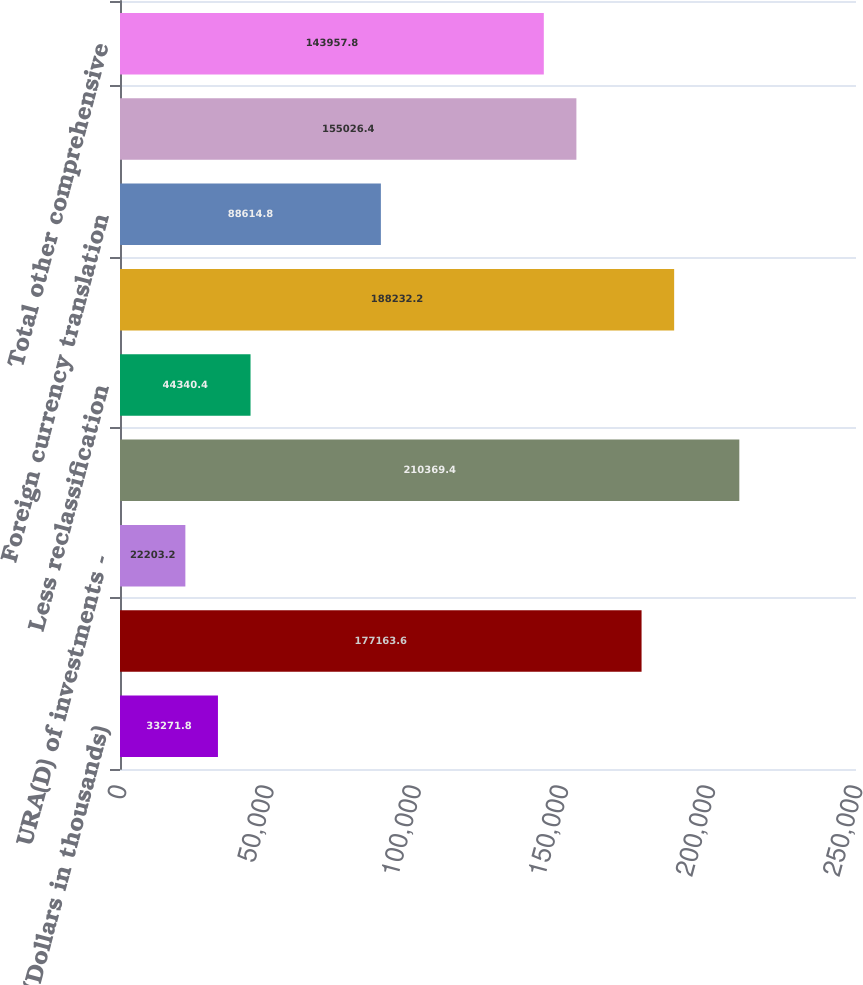Convert chart to OTSL. <chart><loc_0><loc_0><loc_500><loc_500><bar_chart><fcel>(Dollars in thousands)<fcel>Net income (loss)<fcel>URA(D) of investments -<fcel>URA(D) on securities arising<fcel>Less reclassification<fcel>Total URA(D) on securities<fcel>Foreign currency translation<fcel>Pension adjustments<fcel>Total other comprehensive<nl><fcel>33271.8<fcel>177164<fcel>22203.2<fcel>210369<fcel>44340.4<fcel>188232<fcel>88614.8<fcel>155026<fcel>143958<nl></chart> 